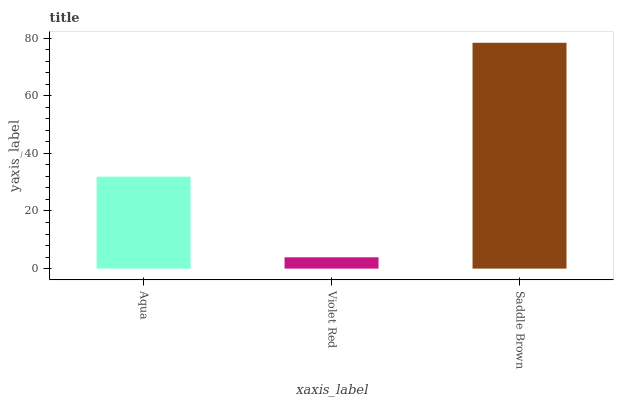Is Violet Red the minimum?
Answer yes or no. Yes. Is Saddle Brown the maximum?
Answer yes or no. Yes. Is Saddle Brown the minimum?
Answer yes or no. No. Is Violet Red the maximum?
Answer yes or no. No. Is Saddle Brown greater than Violet Red?
Answer yes or no. Yes. Is Violet Red less than Saddle Brown?
Answer yes or no. Yes. Is Violet Red greater than Saddle Brown?
Answer yes or no. No. Is Saddle Brown less than Violet Red?
Answer yes or no. No. Is Aqua the high median?
Answer yes or no. Yes. Is Aqua the low median?
Answer yes or no. Yes. Is Violet Red the high median?
Answer yes or no. No. Is Violet Red the low median?
Answer yes or no. No. 